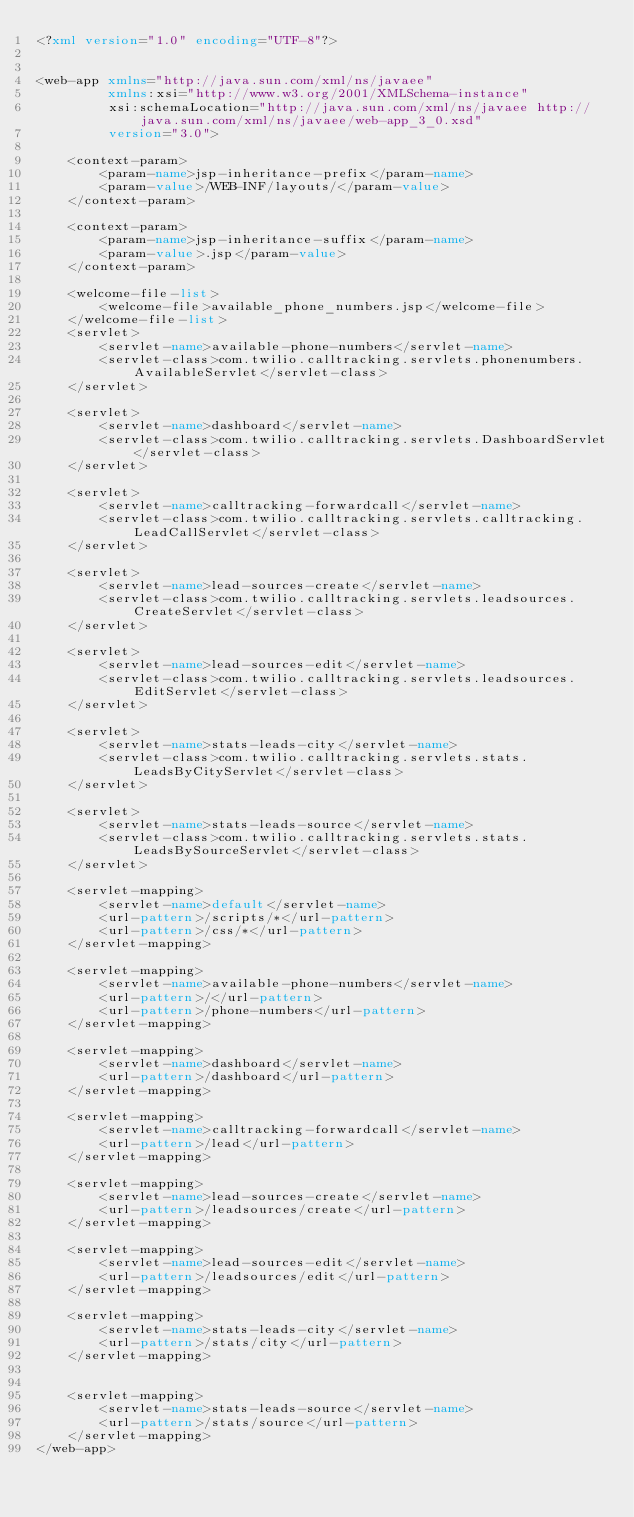Convert code to text. <code><loc_0><loc_0><loc_500><loc_500><_XML_><?xml version="1.0" encoding="UTF-8"?>


<web-app xmlns="http://java.sun.com/xml/ns/javaee"
         xmlns:xsi="http://www.w3.org/2001/XMLSchema-instance"
         xsi:schemaLocation="http://java.sun.com/xml/ns/javaee http://java.sun.com/xml/ns/javaee/web-app_3_0.xsd"
         version="3.0">

    <context-param>
        <param-name>jsp-inheritance-prefix</param-name>
        <param-value>/WEB-INF/layouts/</param-value>
    </context-param>

    <context-param>
        <param-name>jsp-inheritance-suffix</param-name>
        <param-value>.jsp</param-value>
    </context-param>

    <welcome-file-list>
        <welcome-file>available_phone_numbers.jsp</welcome-file>
    </welcome-file-list>
    <servlet>
        <servlet-name>available-phone-numbers</servlet-name>
        <servlet-class>com.twilio.calltracking.servlets.phonenumbers.AvailableServlet</servlet-class>
    </servlet>

    <servlet>
        <servlet-name>dashboard</servlet-name>
        <servlet-class>com.twilio.calltracking.servlets.DashboardServlet</servlet-class>
    </servlet>

    <servlet>
        <servlet-name>calltracking-forwardcall</servlet-name>
        <servlet-class>com.twilio.calltracking.servlets.calltracking.LeadCallServlet</servlet-class>
    </servlet>

    <servlet>
        <servlet-name>lead-sources-create</servlet-name>
        <servlet-class>com.twilio.calltracking.servlets.leadsources.CreateServlet</servlet-class>
    </servlet>

    <servlet>
        <servlet-name>lead-sources-edit</servlet-name>
        <servlet-class>com.twilio.calltracking.servlets.leadsources.EditServlet</servlet-class>
    </servlet>

    <servlet>
        <servlet-name>stats-leads-city</servlet-name>
        <servlet-class>com.twilio.calltracking.servlets.stats.LeadsByCityServlet</servlet-class>
    </servlet>

    <servlet>
        <servlet-name>stats-leads-source</servlet-name>
        <servlet-class>com.twilio.calltracking.servlets.stats.LeadsBySourceServlet</servlet-class>
    </servlet>

    <servlet-mapping>
        <servlet-name>default</servlet-name>
        <url-pattern>/scripts/*</url-pattern>
        <url-pattern>/css/*</url-pattern>
    </servlet-mapping>

    <servlet-mapping>
        <servlet-name>available-phone-numbers</servlet-name>
        <url-pattern>/</url-pattern>
        <url-pattern>/phone-numbers</url-pattern>
    </servlet-mapping>

    <servlet-mapping>
        <servlet-name>dashboard</servlet-name>
        <url-pattern>/dashboard</url-pattern>
    </servlet-mapping>

    <servlet-mapping>
        <servlet-name>calltracking-forwardcall</servlet-name>
        <url-pattern>/lead</url-pattern>
    </servlet-mapping>

    <servlet-mapping>
        <servlet-name>lead-sources-create</servlet-name>
        <url-pattern>/leadsources/create</url-pattern>
    </servlet-mapping>

    <servlet-mapping>
        <servlet-name>lead-sources-edit</servlet-name>
        <url-pattern>/leadsources/edit</url-pattern>
    </servlet-mapping>

    <servlet-mapping>
        <servlet-name>stats-leads-city</servlet-name>
        <url-pattern>/stats/city</url-pattern>
    </servlet-mapping>


    <servlet-mapping>
        <servlet-name>stats-leads-source</servlet-name>
        <url-pattern>/stats/source</url-pattern>
    </servlet-mapping>
</web-app>
</code> 